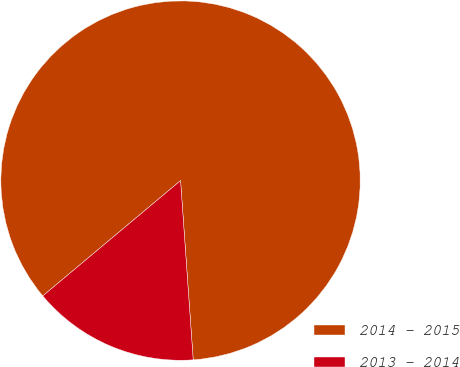Convert chart. <chart><loc_0><loc_0><loc_500><loc_500><pie_chart><fcel>2014 - 2015<fcel>2013 - 2014<nl><fcel>84.97%<fcel>15.03%<nl></chart> 